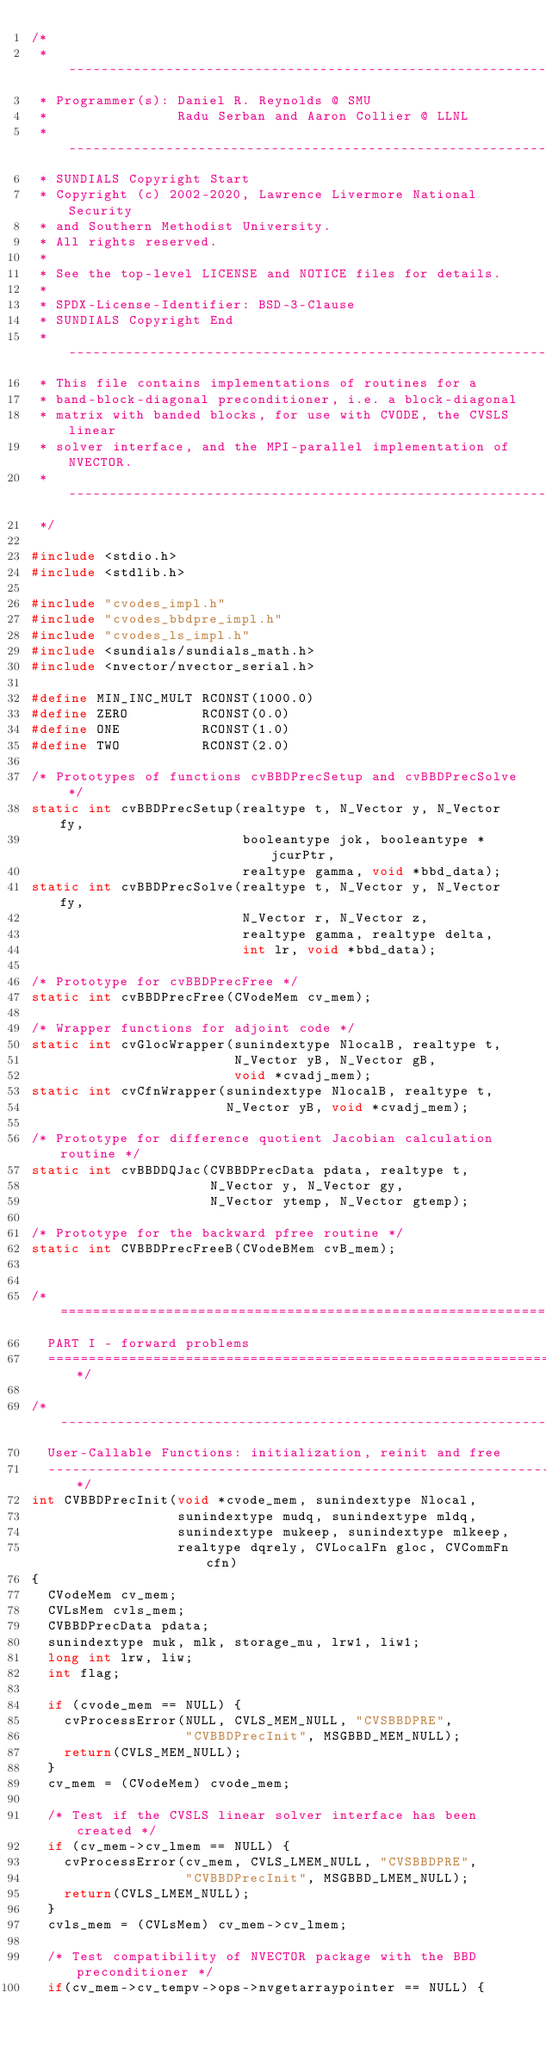Convert code to text. <code><loc_0><loc_0><loc_500><loc_500><_C_>/*
 * -----------------------------------------------------------------
 * Programmer(s): Daniel R. Reynolds @ SMU
 *                Radu Serban and Aaron Collier @ LLNL
 * -----------------------------------------------------------------
 * SUNDIALS Copyright Start
 * Copyright (c) 2002-2020, Lawrence Livermore National Security
 * and Southern Methodist University.
 * All rights reserved.
 *
 * See the top-level LICENSE and NOTICE files for details.
 *
 * SPDX-License-Identifier: BSD-3-Clause
 * SUNDIALS Copyright End
 * -----------------------------------------------------------------
 * This file contains implementations of routines for a
 * band-block-diagonal preconditioner, i.e. a block-diagonal
 * matrix with banded blocks, for use with CVODE, the CVSLS linear
 * solver interface, and the MPI-parallel implementation of NVECTOR.
 * -----------------------------------------------------------------
 */

#include <stdio.h>
#include <stdlib.h>

#include "cvodes_impl.h"
#include "cvodes_bbdpre_impl.h"
#include "cvodes_ls_impl.h"
#include <sundials/sundials_math.h>
#include <nvector/nvector_serial.h>

#define MIN_INC_MULT RCONST(1000.0)
#define ZERO         RCONST(0.0)
#define ONE          RCONST(1.0)
#define TWO          RCONST(2.0)

/* Prototypes of functions cvBBDPrecSetup and cvBBDPrecSolve */
static int cvBBDPrecSetup(realtype t, N_Vector y, N_Vector fy,
                          booleantype jok, booleantype *jcurPtr,
                          realtype gamma, void *bbd_data);
static int cvBBDPrecSolve(realtype t, N_Vector y, N_Vector fy,
                          N_Vector r, N_Vector z,
                          realtype gamma, realtype delta,
                          int lr, void *bbd_data);

/* Prototype for cvBBDPrecFree */
static int cvBBDPrecFree(CVodeMem cv_mem);

/* Wrapper functions for adjoint code */
static int cvGlocWrapper(sunindextype NlocalB, realtype t,
                         N_Vector yB, N_Vector gB,
                         void *cvadj_mem);
static int cvCfnWrapper(sunindextype NlocalB, realtype t,
                        N_Vector yB, void *cvadj_mem);

/* Prototype for difference quotient Jacobian calculation routine */
static int cvBBDDQJac(CVBBDPrecData pdata, realtype t,
                      N_Vector y, N_Vector gy,
                      N_Vector ytemp, N_Vector gtemp);

/* Prototype for the backward pfree routine */
static int CVBBDPrecFreeB(CVodeBMem cvB_mem);


/*================================================================
  PART I - forward problems
  ================================================================*/

/*-----------------------------------------------------------------
  User-Callable Functions: initialization, reinit and free
  -----------------------------------------------------------------*/
int CVBBDPrecInit(void *cvode_mem, sunindextype Nlocal,
                  sunindextype mudq, sunindextype mldq,
                  sunindextype mukeep, sunindextype mlkeep,
                  realtype dqrely, CVLocalFn gloc, CVCommFn cfn)
{
  CVodeMem cv_mem;
  CVLsMem cvls_mem;
  CVBBDPrecData pdata;
  sunindextype muk, mlk, storage_mu, lrw1, liw1;
  long int lrw, liw;
  int flag;

  if (cvode_mem == NULL) {
    cvProcessError(NULL, CVLS_MEM_NULL, "CVSBBDPRE",
                   "CVBBDPrecInit", MSGBBD_MEM_NULL);
    return(CVLS_MEM_NULL);
  }
  cv_mem = (CVodeMem) cvode_mem;

  /* Test if the CVSLS linear solver interface has been created */
  if (cv_mem->cv_lmem == NULL) {
    cvProcessError(cv_mem, CVLS_LMEM_NULL, "CVSBBDPRE",
                   "CVBBDPrecInit", MSGBBD_LMEM_NULL);
    return(CVLS_LMEM_NULL);
  }
  cvls_mem = (CVLsMem) cv_mem->cv_lmem;

  /* Test compatibility of NVECTOR package with the BBD preconditioner */
  if(cv_mem->cv_tempv->ops->nvgetarraypointer == NULL) {</code> 